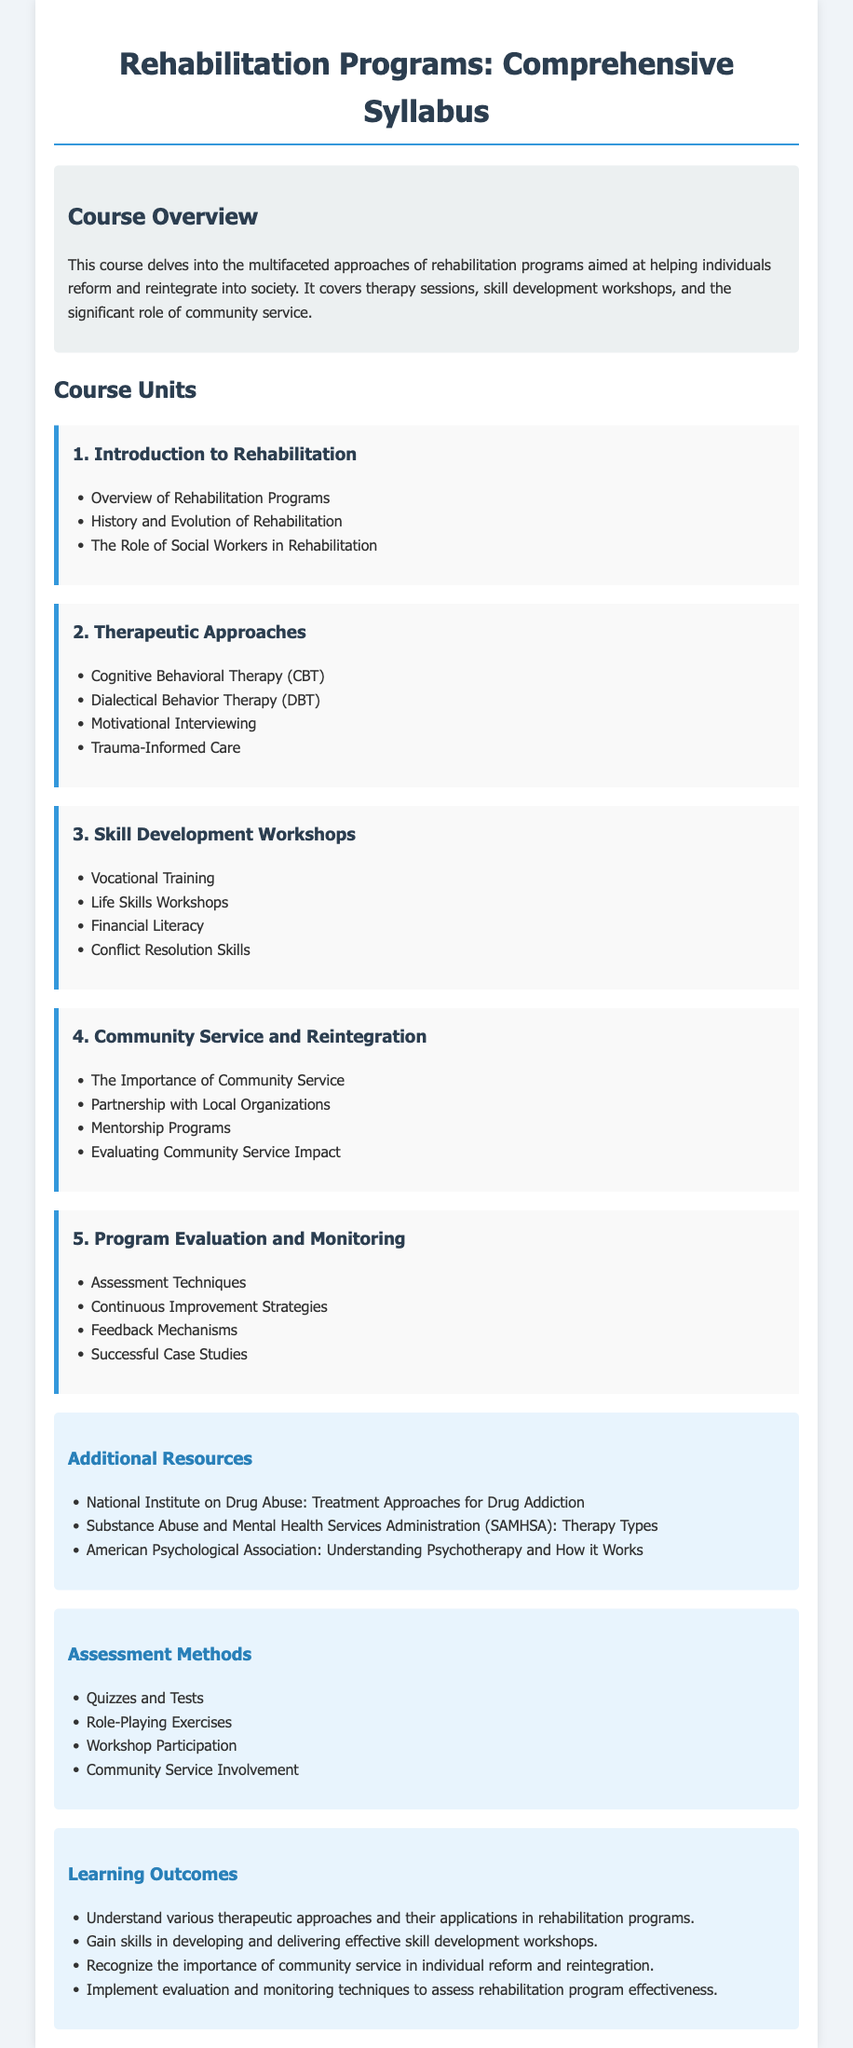what is the title of the syllabus? The title of the syllabus is prominently displayed at the top of the document as "Rehabilitation Programs: Comprehensive Syllabus."
Answer: Rehabilitation Programs: Comprehensive Syllabus how many course units are there? The document lists a total of five course units under the "Course Units" section.
Answer: 5 which therapeutic approach involves understanding and addressing past trauma? The document mentions "Trauma-Informed Care" as the therapeutic approach focused on understanding and addressing past trauma.
Answer: Trauma-Informed Care what is one of the skill development topics covered in the workshops? One of the skill development topics listed in the syllabus is "Financial Literacy."
Answer: Financial Literacy what method is included for assessing community service involvement? The assessment methods section includes "Community Service Involvement" as one of the methods for evaluation.
Answer: Community Service Involvement what is the importance of community service as mentioned in the syllabus? The syllabus highlights the "Importance of Community Service" in the context of rehabilitation and reintegration of individuals.
Answer: Importance of Community Service name one organization mentioned in the additional resources. The syllabus lists "Substance Abuse and Mental Health Services Administration (SAMHSA)" as one of the organizations in the additional resources.
Answer: Substance Abuse and Mental Health Services Administration which two types of exercises are used for assessment in the syllabus? The assessment methods include "Role-Playing Exercises" and "Quizzes and Tests" as types of exercises.
Answer: Role-Playing Exercises, Quizzes and Tests what is one expected learning outcome from the course? The syllabus outlines that students will learn to "Understand various therapeutic approaches and their applications in rehabilitation programs."
Answer: Understand various therapeutic approaches and their applications in rehabilitation programs 